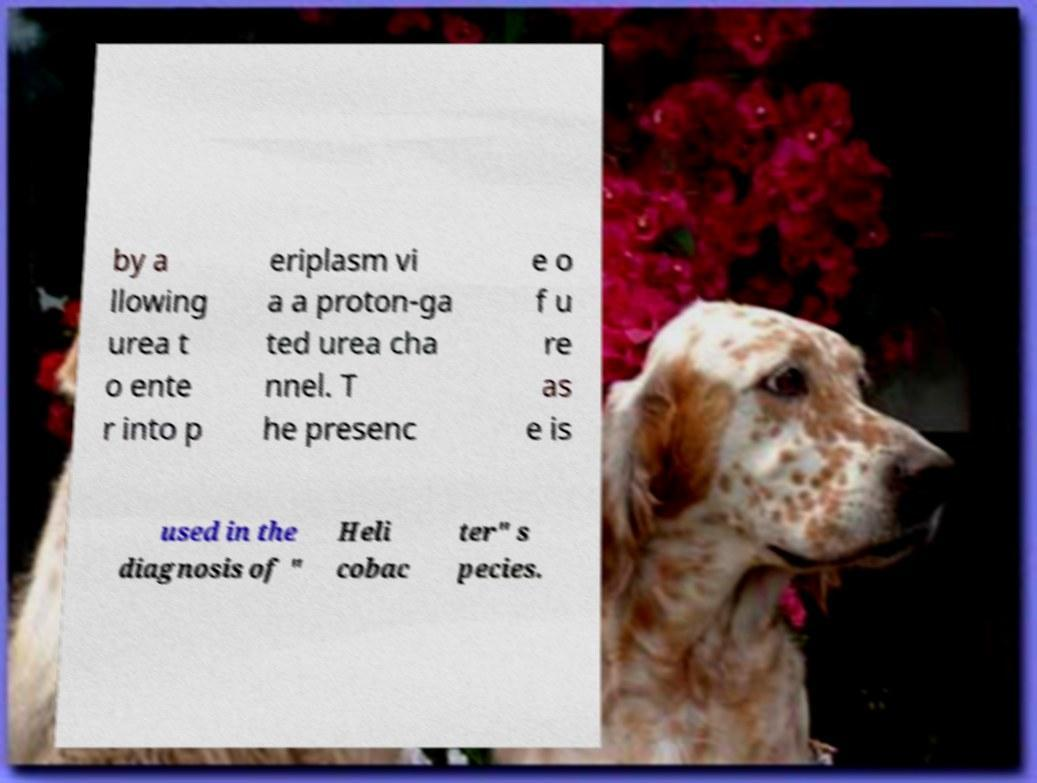Could you assist in decoding the text presented in this image and type it out clearly? by a llowing urea t o ente r into p eriplasm vi a a proton-ga ted urea cha nnel. T he presenc e o f u re as e is used in the diagnosis of " Heli cobac ter" s pecies. 